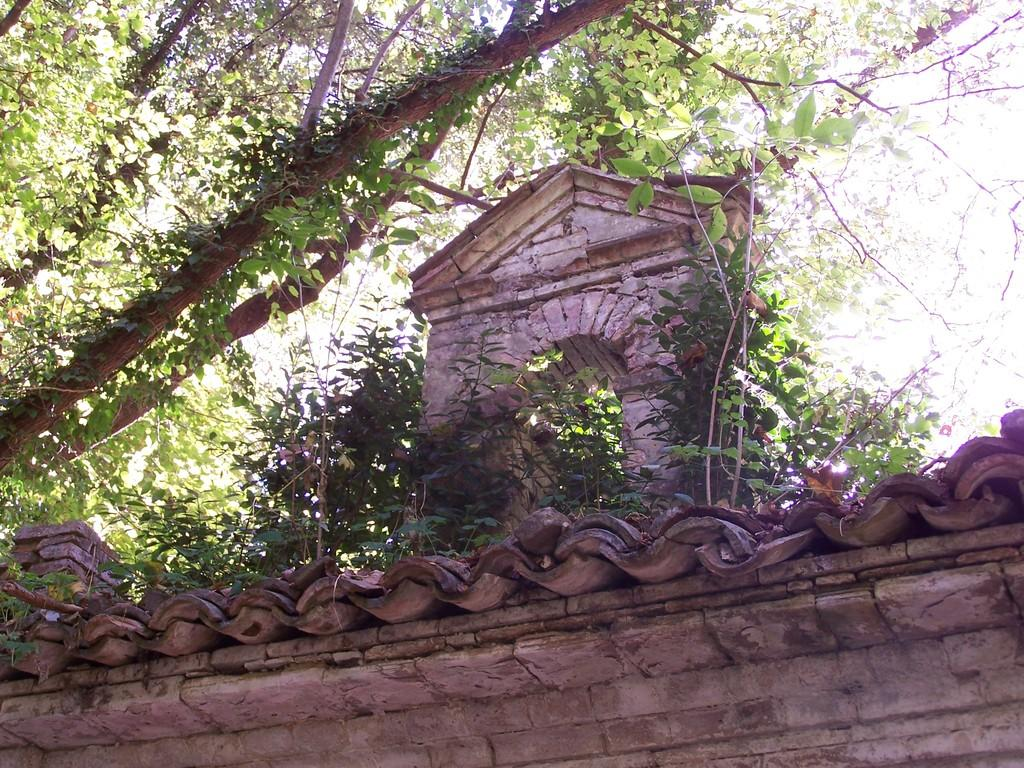What type of structure can be seen in the image? There is a wall and a rooftop in the image. What type of vegetation is present in the image? Leaves, branches, and stems are visible in the image. Can you see a zebra smiling on the shelf in the image? There is no zebra or shelf present in the image. 